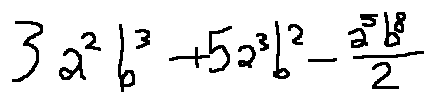<formula> <loc_0><loc_0><loc_500><loc_500>3 a ^ { 2 } b ^ { 3 } + 5 a ^ { 3 } b ^ { 2 } - \frac { a ^ { 5 } b ^ { 8 } } { 2 }</formula> 